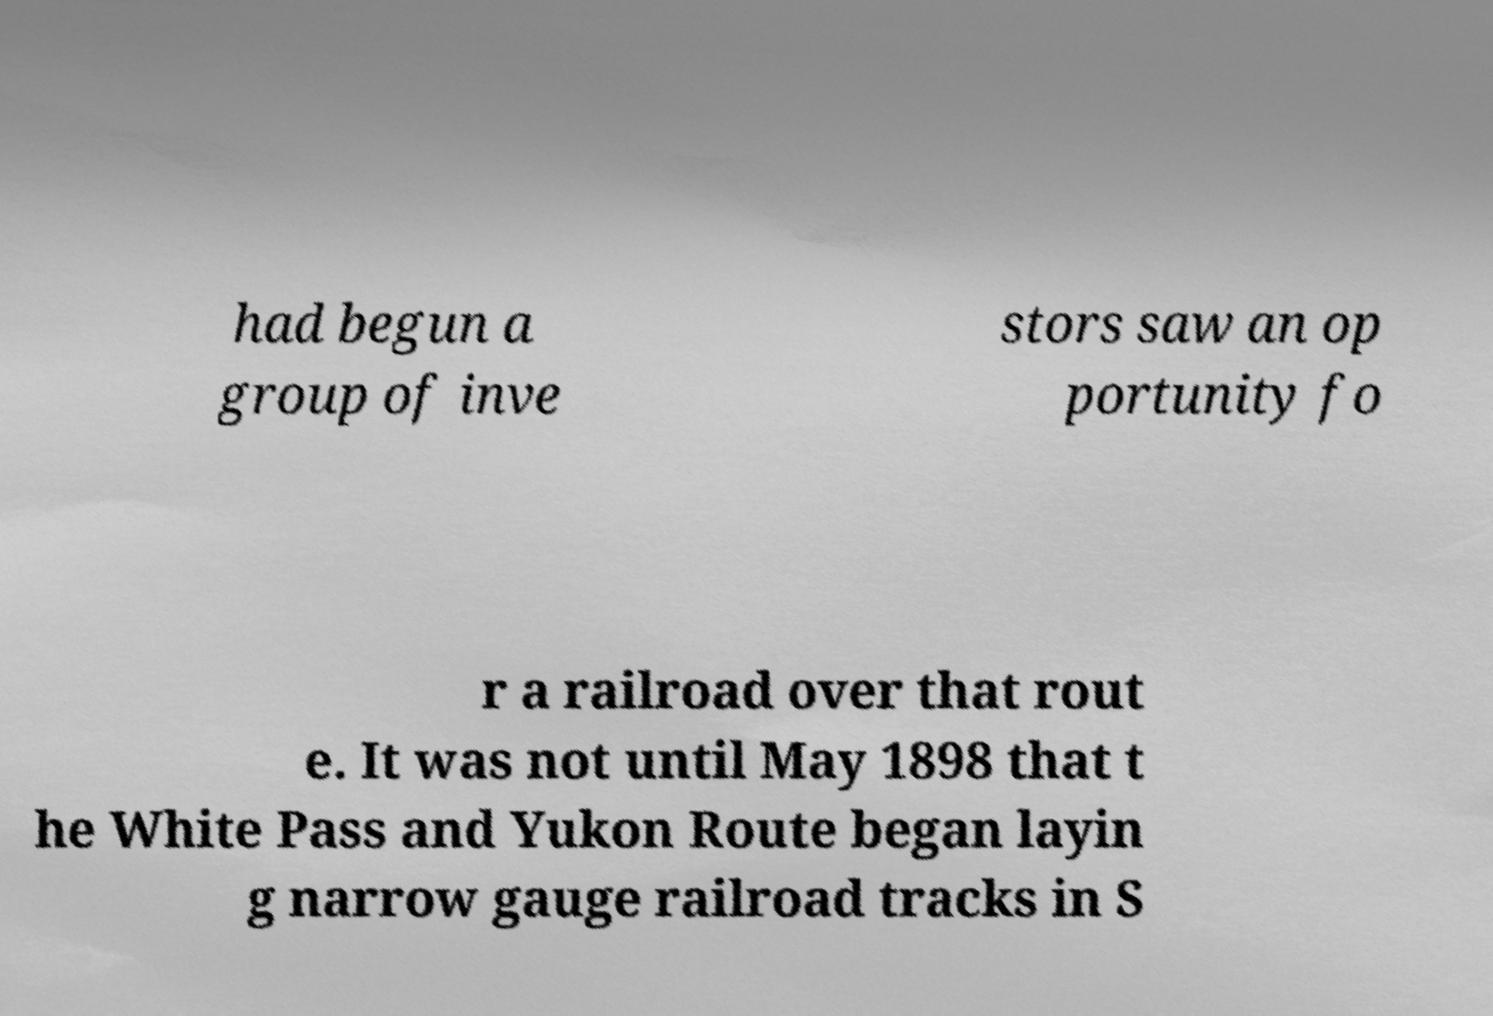Please read and relay the text visible in this image. What does it say? had begun a group of inve stors saw an op portunity fo r a railroad over that rout e. It was not until May 1898 that t he White Pass and Yukon Route began layin g narrow gauge railroad tracks in S 